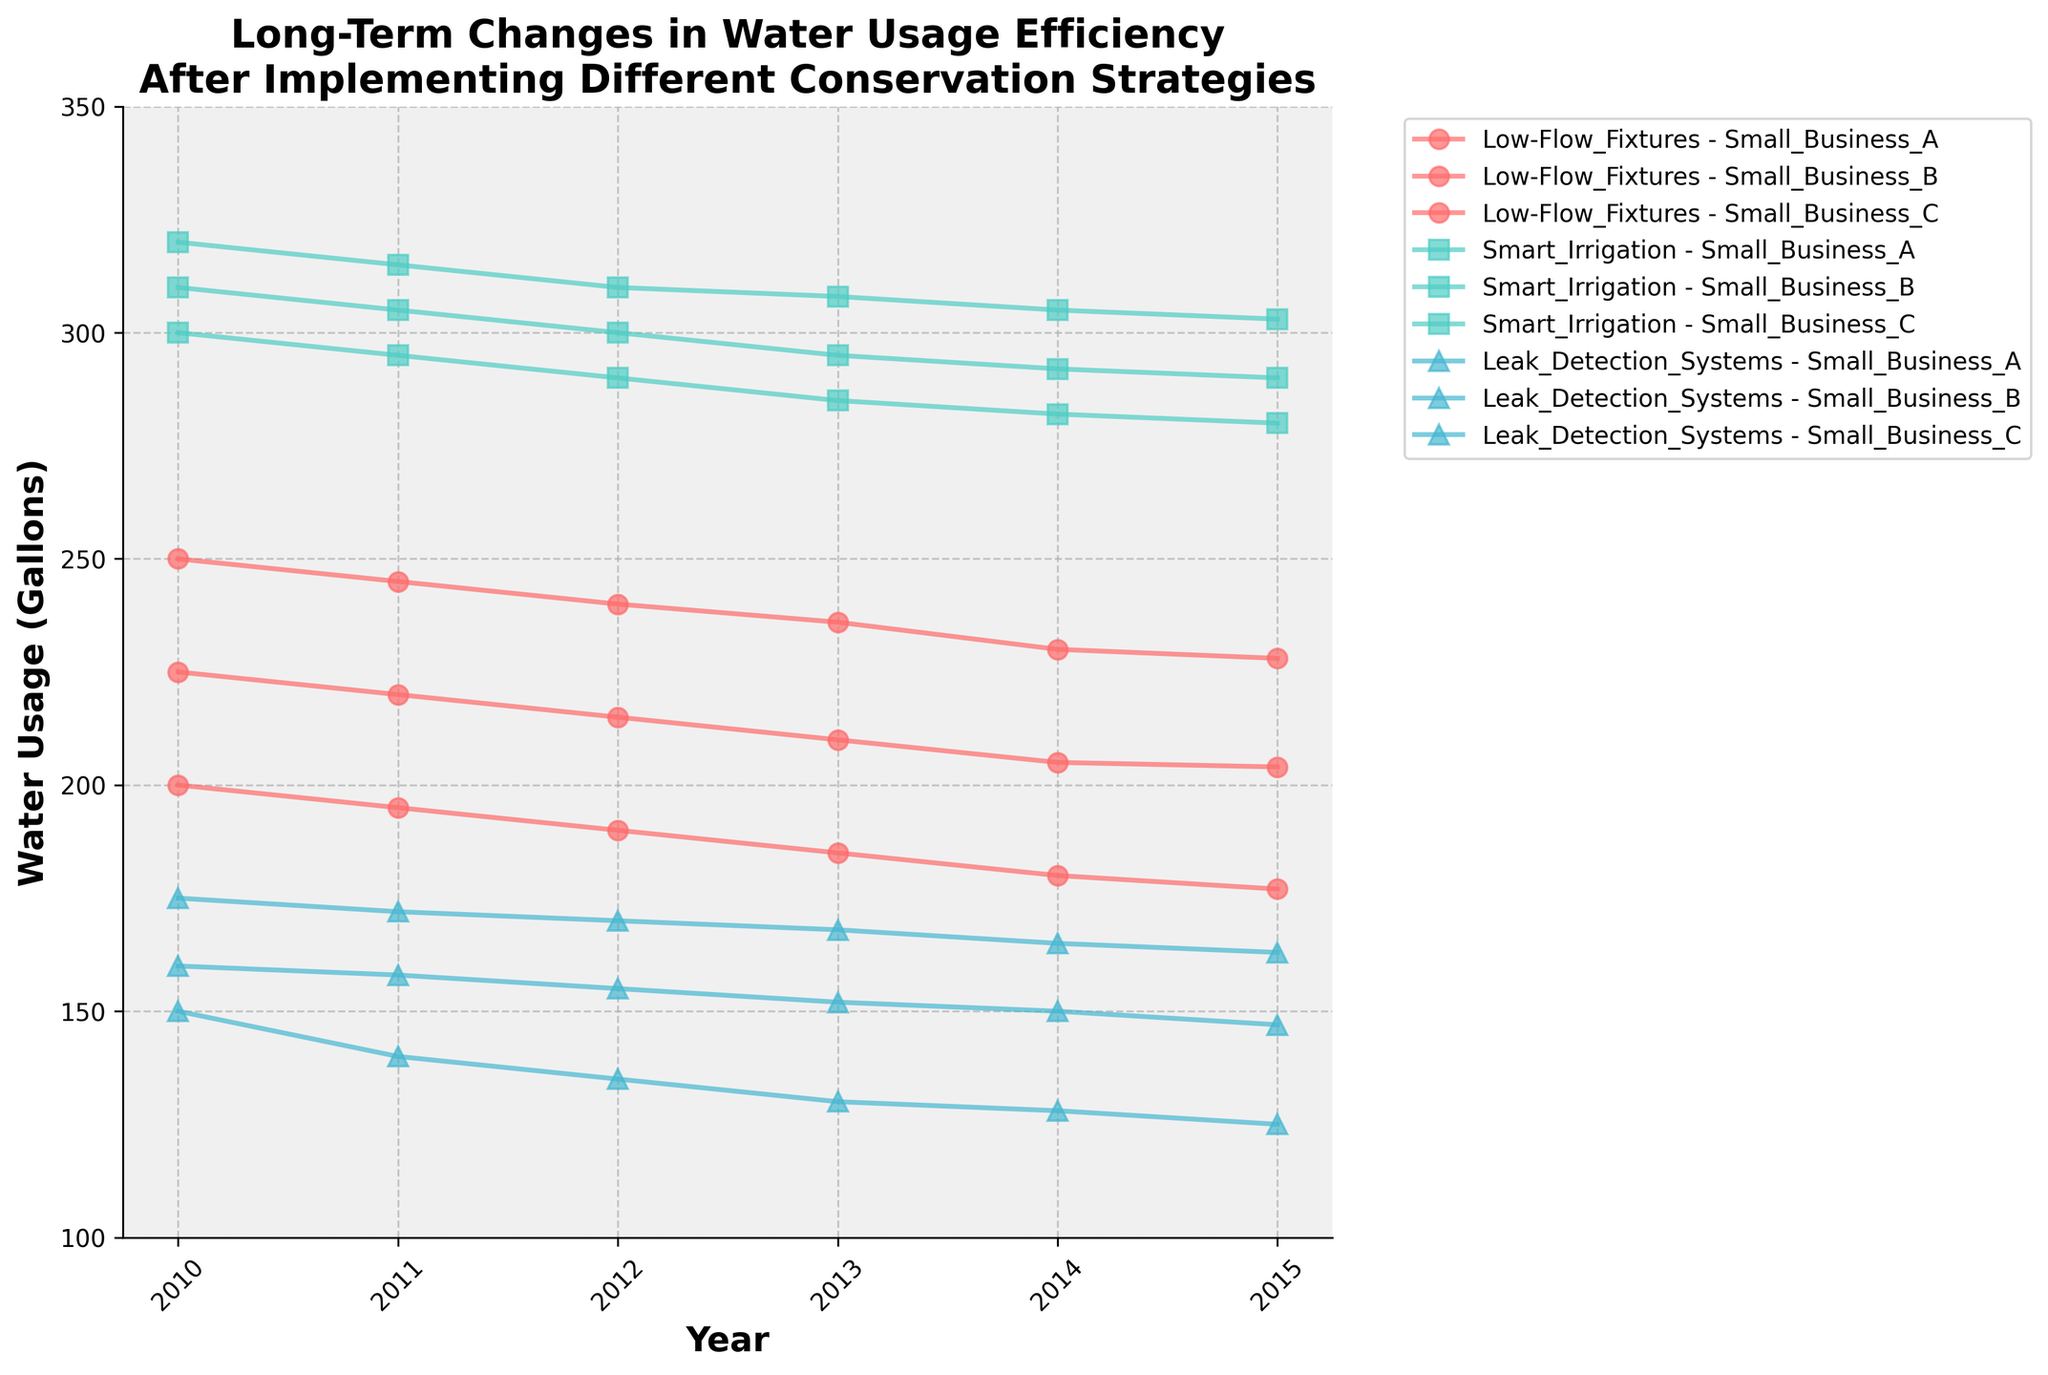What is the title of the plot? The title of the plot is displayed prominently at the top. It reads "Long-Term Changes in Water Usage Efficiency After Implementing Different Conservation Strategies."
Answer: Long-Term Changes in Water Usage Efficiency After Implementing Different Conservation Strategies How does the water usage for Small Business A change over time with Low-Flow Fixtures installed? By looking at the line corresponding to Small Business A under the Low-Flow Fixtures strategy, we can see a consistent decrease in water usage from 200 gallons in 2010 to 177 gallons in 2015.
Answer: Decreases from 200 gallons to 177 gallons Which conservation strategy leads to the highest initial water usage for Small Business B in 2010? By comparing the initial values in 2010 for all three strategies for Small Business B, we see that Smart Irrigation shows the highest initial water usage at 320 gallons.
Answer: Smart Irrigation When considering the Smart Irrigation strategy, how much lower is the water usage for Small Business C in 2015 compared to 2010? The water usage for Small Business C under Smart Irrigation was 310 gallons in 2010 and decreased to 290 gallons in 2015. The difference is 310 - 290 = 20 gallons.
Answer: 20 gallons Which business shows the lowest water usage in 2015 under the Leak Detection Systems strategy? By inspecting the values in 2015 for all businesses under the Leak Detection Systems strategy, Small Business C shows the lowest water usage at 147 gallons.
Answer: Small Business C How many unique conservation strategies are compared in this figure? The plot shows three distinct conservation strategies, which are Low-Flow Fixtures, Smart Irrigation, and Leak Detection Systems.
Answer: Three For Small Business B, which strategy shows the least reduction in water usage over the six years? Comparing the decrease in water usage from 2010 to 2015 for Small Business B, we observe: Low-Flow Fixtures: 250 to 228 (22 gallons), Smart Irrigation: 320 to 303 (17 gallons), Leak Detection Systems: 175 to 163 (12 gallons). The least reduction is under the Leak Detection Systems strategy with a decrease of 12 gallons.
Answer: Leak Detection Systems What is the general trend of water usage over time for all businesses under the Leak Detection Systems strategy? Looking at the lines corresponding to Leak Detection Systems, we notice a downward trend, indicating that water usage generally decreases over the years from 2010 to 2015 for all businesses.
Answer: Decreasing trend Comparing the efficiency of Low-Flow Fixtures to Smart Irrigation, which strategy shows a greater overall reduction in water usage for Small Business A from 2010 to 2015? Low-Flow Fixtures decreases from 200 to 177 gallons (23 gallons), while Smart Irrigation decreases from 300 to 280 gallons (20 gallons). Thus, Low-Flow Fixtures show a greater overall reduction for Small Business A.
Answer: Low-Flow Fixtures What is the difference in water usage in the year 2013 between Small Business A using Low-Flow Fixtures and Small Business B using Smart Irrigation? In 2013, the water usage for Small Business A under Low-Flow Fixtures was 185 gallons, and for Small Business B under Smart Irrigation, it was 308 gallons. The difference is 308 - 185 = 123 gallons.
Answer: 123 gallons 